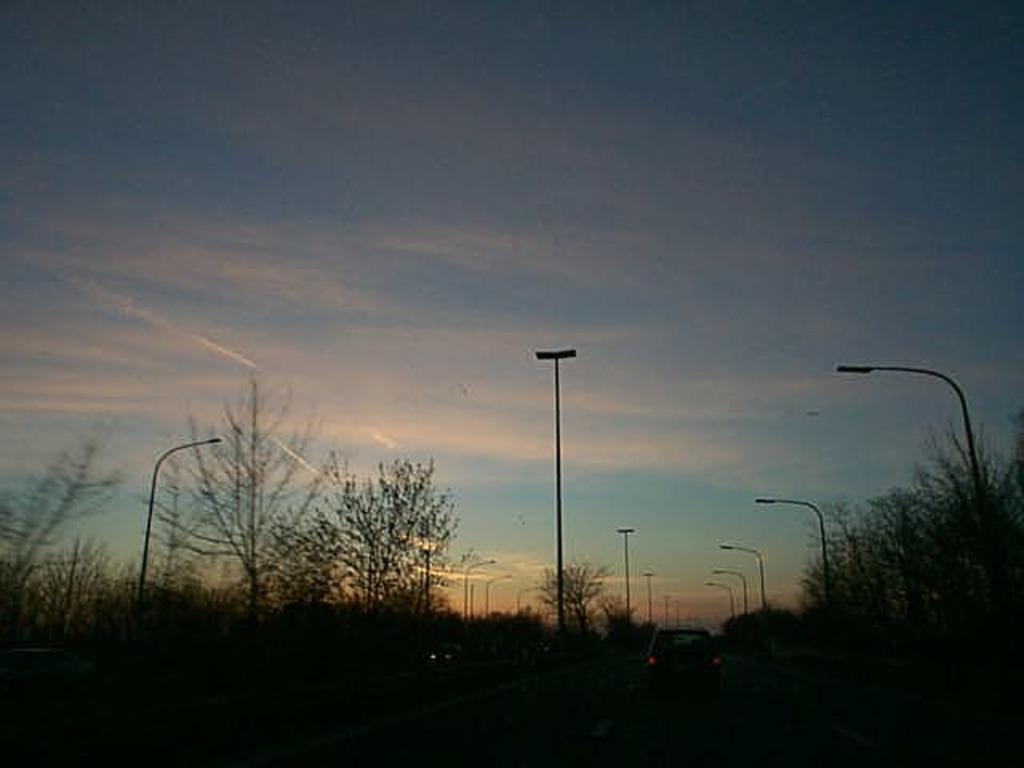What type of natural elements can be seen in the image? There are trees in the image. What type of artificial elements can be seen in the image? There are street lights in the image. What type of man-made object is present on the road in the image? There is a vehicle on the road in the image. What is visible in the background of the image? The sky is visible in the background of the image. What month is it in the image? The month cannot be determined from the image, as there is no information about the time of year or any specific seasonal elements present. Can you tell me how many lawyers are in the image? There are no lawyers present in the image. 